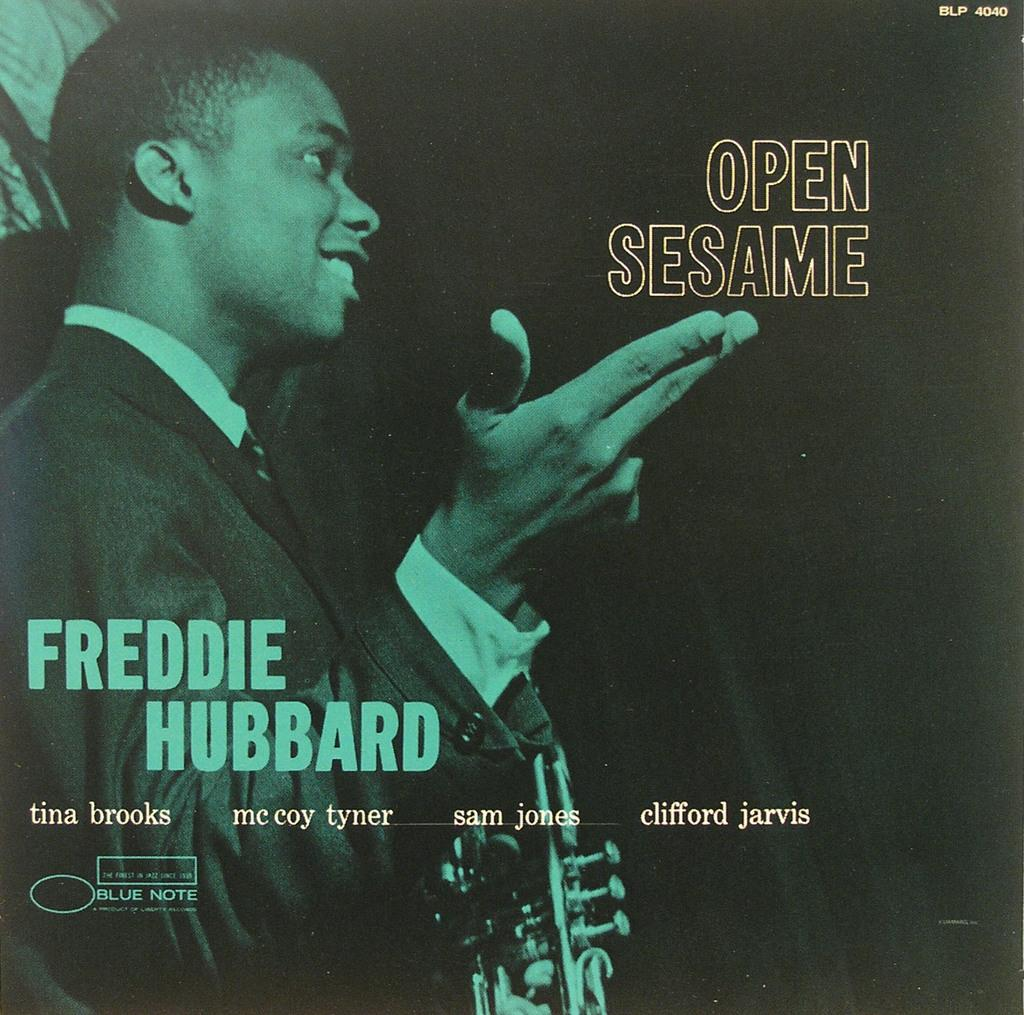<image>
Render a clear and concise summary of the photo. Freddie Hubbard holds a trumpet, posing with his other hand in the shape of a gun. 